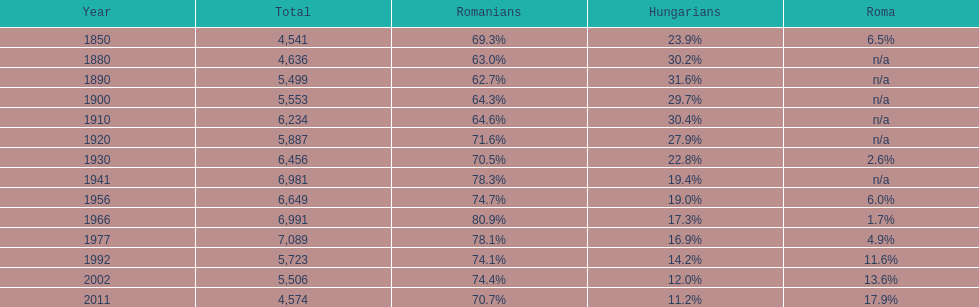What year had the next highest percentage for roma after 2011? 2002. 